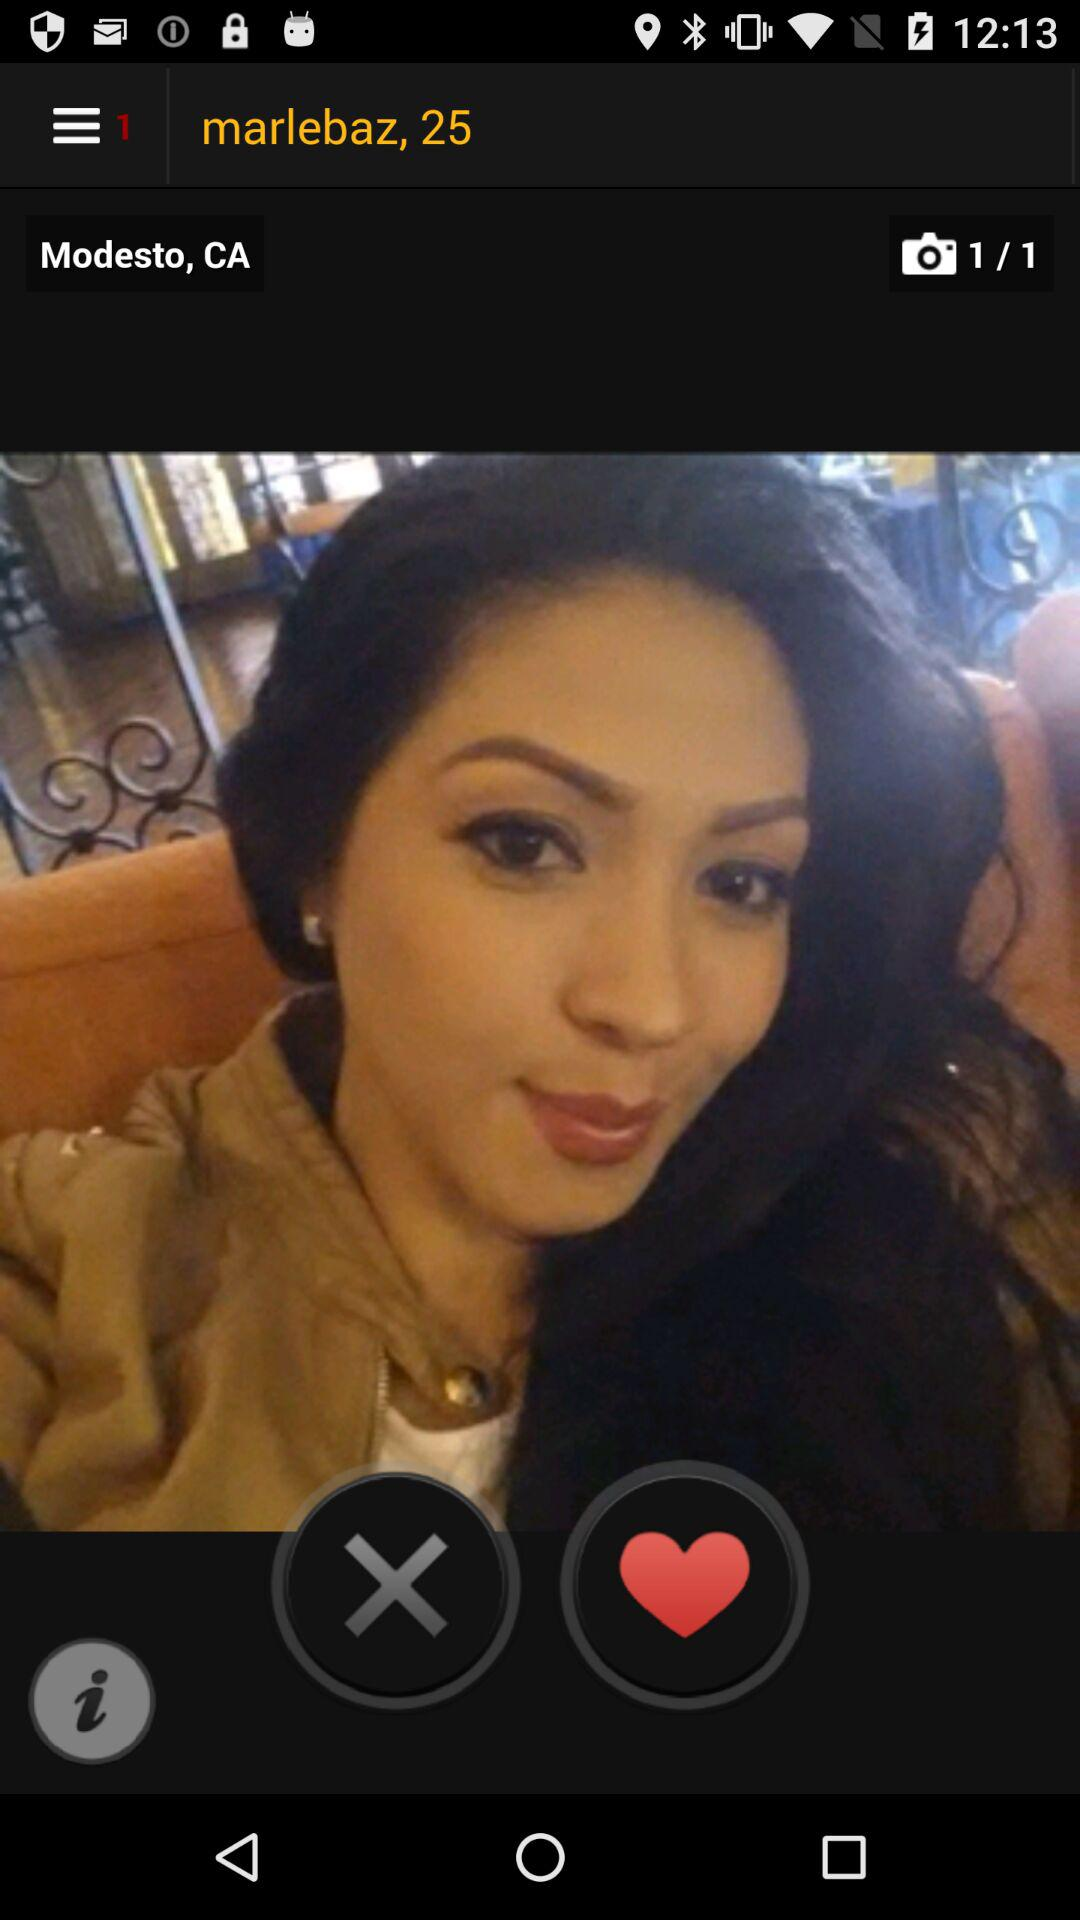What is the name? The name is Marlebaz. 